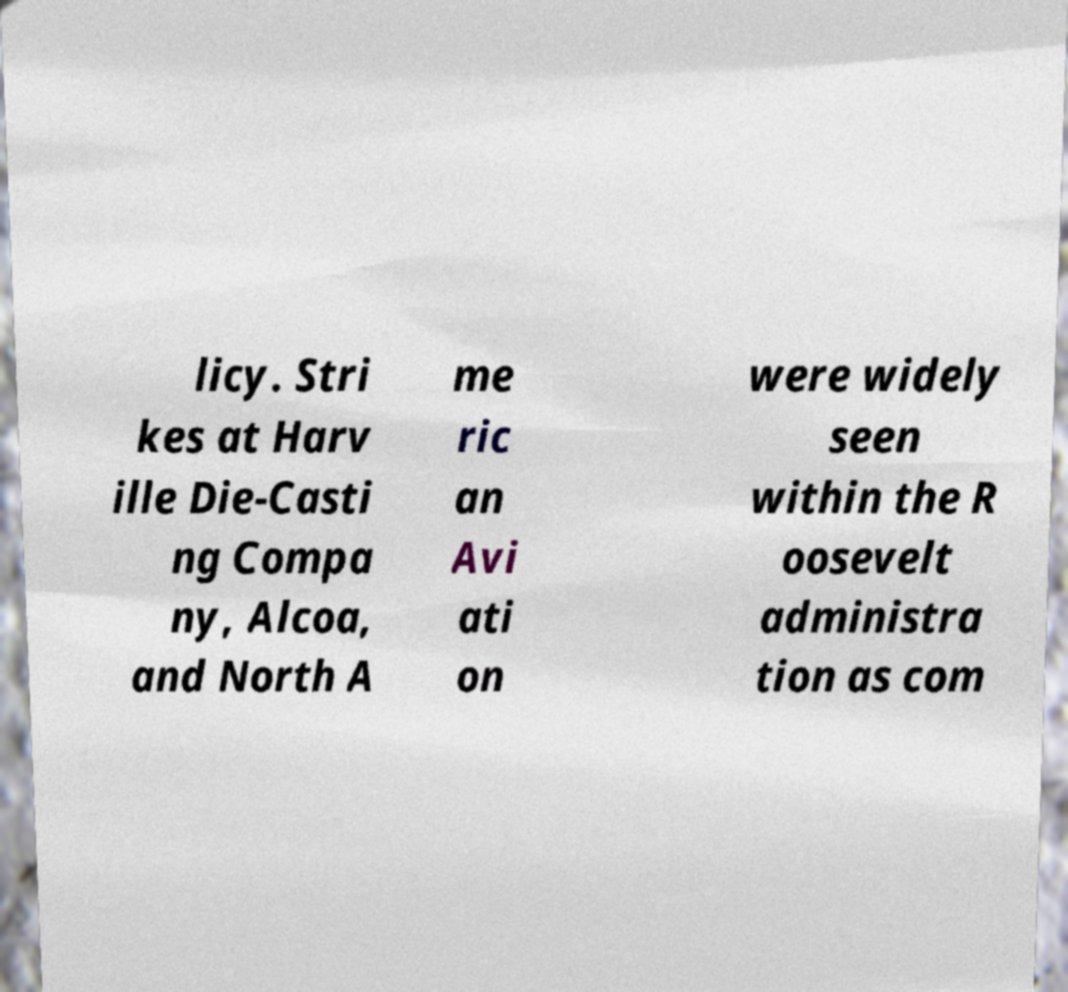Please read and relay the text visible in this image. What does it say? licy. Stri kes at Harv ille Die-Casti ng Compa ny, Alcoa, and North A me ric an Avi ati on were widely seen within the R oosevelt administra tion as com 